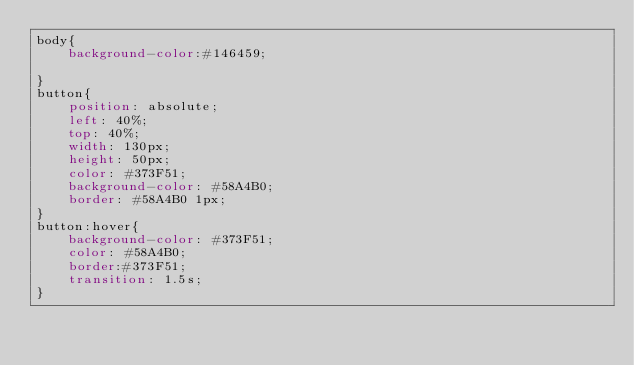<code> <loc_0><loc_0><loc_500><loc_500><_CSS_>body{
    background-color:#146459;
       
}
button{
    position: absolute;
    left: 40%;
    top: 40%;
    width: 130px;
    height: 50px;
    color: #373F51;
    background-color: #58A4B0;
    border: #58A4B0 1px;
}
button:hover{
    background-color: #373F51;
    color: #58A4B0;
    border:#373F51;
    transition: 1.5s;
}</code> 